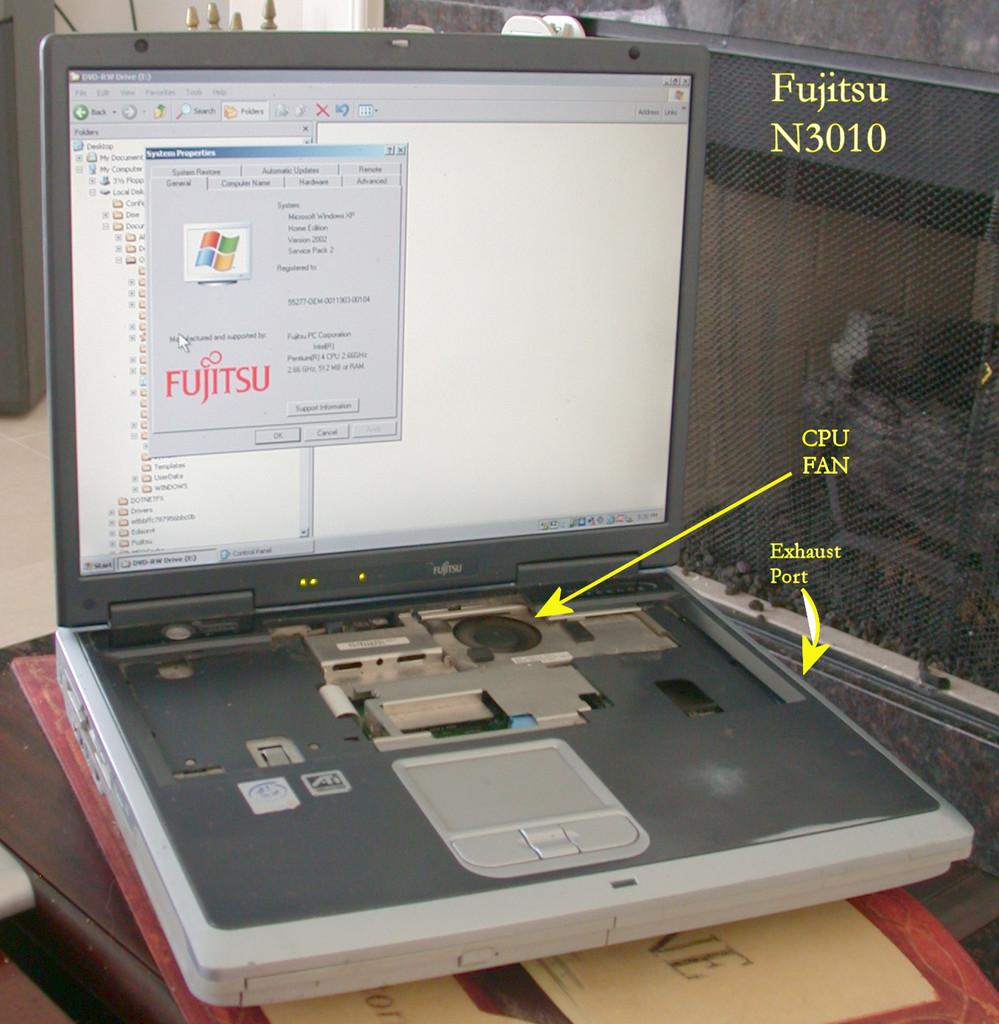<image>
Offer a succinct explanation of the picture presented. A Fujitsu N3010 is opened up to show the CPU fan and exhaust port. 